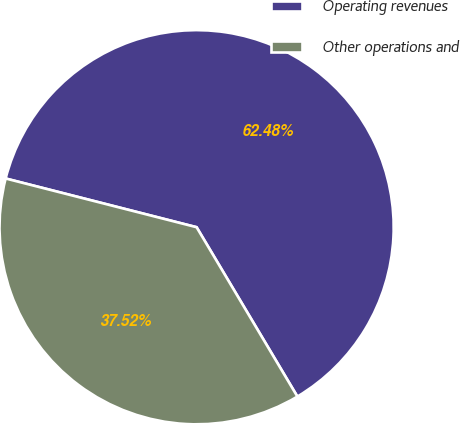Convert chart. <chart><loc_0><loc_0><loc_500><loc_500><pie_chart><fcel>Operating revenues<fcel>Other operations and<nl><fcel>62.48%<fcel>37.52%<nl></chart> 